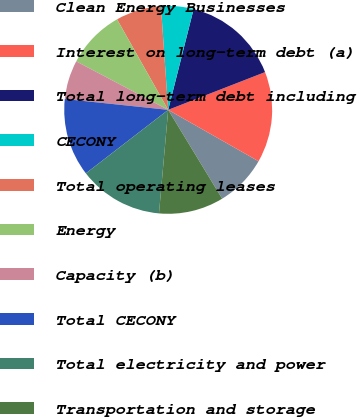Convert chart to OTSL. <chart><loc_0><loc_0><loc_500><loc_500><pie_chart><fcel>Clean Energy Businesses<fcel>Interest on long-term debt (a)<fcel>Total long-term debt including<fcel>CECONY<fcel>Total operating leases<fcel>Energy<fcel>Capacity (b)<fcel>Total CECONY<fcel>Total electricity and power<fcel>Transportation and storage<nl><fcel>8.08%<fcel>14.14%<fcel>15.15%<fcel>5.05%<fcel>7.07%<fcel>9.09%<fcel>6.06%<fcel>12.12%<fcel>13.13%<fcel>10.1%<nl></chart> 